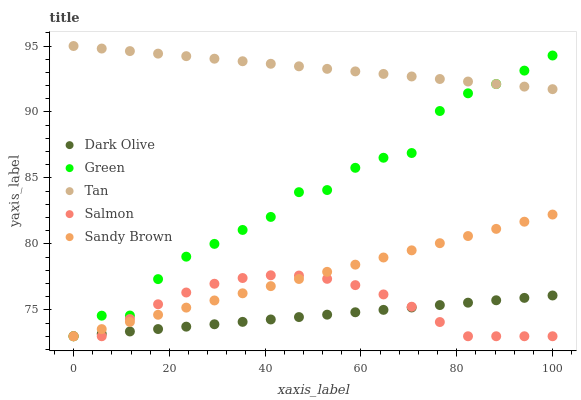Does Dark Olive have the minimum area under the curve?
Answer yes or no. Yes. Does Tan have the maximum area under the curve?
Answer yes or no. Yes. Does Tan have the minimum area under the curve?
Answer yes or no. No. Does Dark Olive have the maximum area under the curve?
Answer yes or no. No. Is Sandy Brown the smoothest?
Answer yes or no. Yes. Is Green the roughest?
Answer yes or no. Yes. Is Tan the smoothest?
Answer yes or no. No. Is Tan the roughest?
Answer yes or no. No. Does Salmon have the lowest value?
Answer yes or no. Yes. Does Tan have the lowest value?
Answer yes or no. No. Does Tan have the highest value?
Answer yes or no. Yes. Does Dark Olive have the highest value?
Answer yes or no. No. Is Dark Olive less than Tan?
Answer yes or no. Yes. Is Tan greater than Salmon?
Answer yes or no. Yes. Does Green intersect Salmon?
Answer yes or no. Yes. Is Green less than Salmon?
Answer yes or no. No. Is Green greater than Salmon?
Answer yes or no. No. Does Dark Olive intersect Tan?
Answer yes or no. No. 